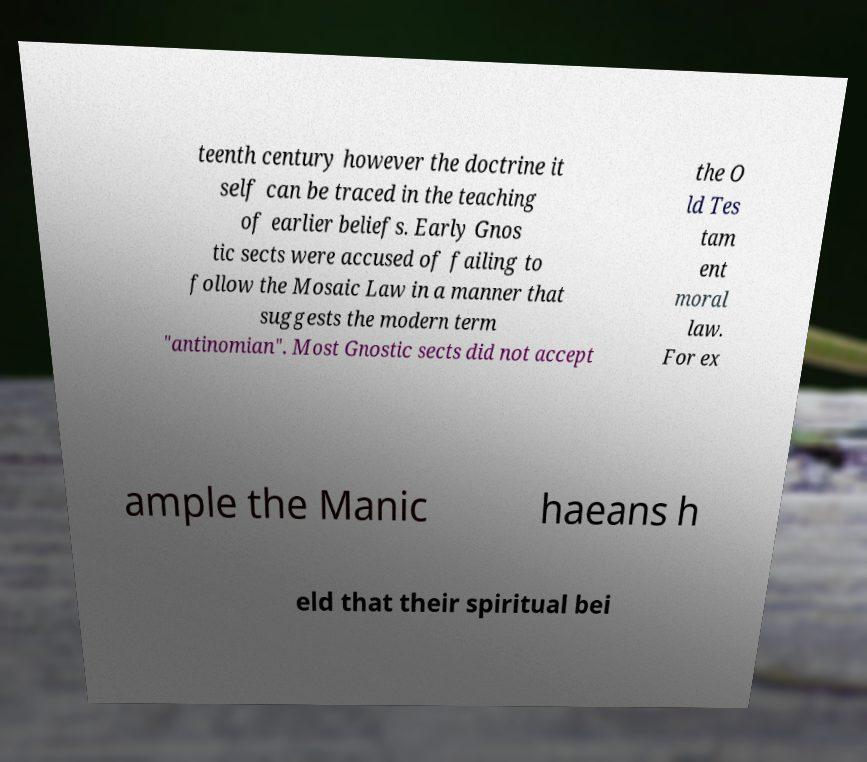Please identify and transcribe the text found in this image. teenth century however the doctrine it self can be traced in the teaching of earlier beliefs. Early Gnos tic sects were accused of failing to follow the Mosaic Law in a manner that suggests the modern term "antinomian". Most Gnostic sects did not accept the O ld Tes tam ent moral law. For ex ample the Manic haeans h eld that their spiritual bei 